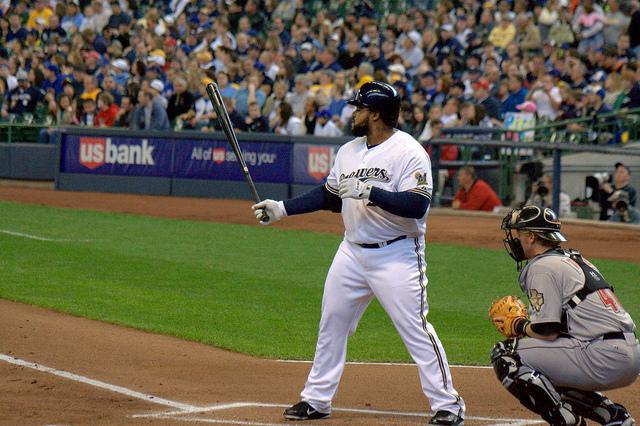Which arm is the player holding out straight?
Quick response, please. Right. What team is the player in white on?
Short answer required. Brewers. What bank is represented?
Answer briefly. Us bank. What game are they playing?
Short answer required. Baseball. What number is on the baseball sign attached to the fence?
Short answer required. 0. How many baseball players are pictured?
Short answer required. 2. For what team does this man play?
Give a very brief answer. Brewers. What team does he play for?
Give a very brief answer. Brewers. What teams are playing?
Quick response, please. Brewers. What sponsor is on the fence?
Quick response, please. Us bank. How many empty seats are there?
Write a very short answer. 0. What is the title of the player?
Quick response, please. Batter. 